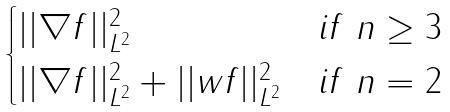Convert formula to latex. <formula><loc_0><loc_0><loc_500><loc_500>\begin{cases} | | \nabla f | | _ { L ^ { 2 } } ^ { 2 } & i f \ n \geq 3 \\ | | \nabla f | | _ { L ^ { 2 } } ^ { 2 } + | | w f | | _ { L ^ { 2 } } ^ { 2 } & i f \ n = 2 \end{cases}</formula> 